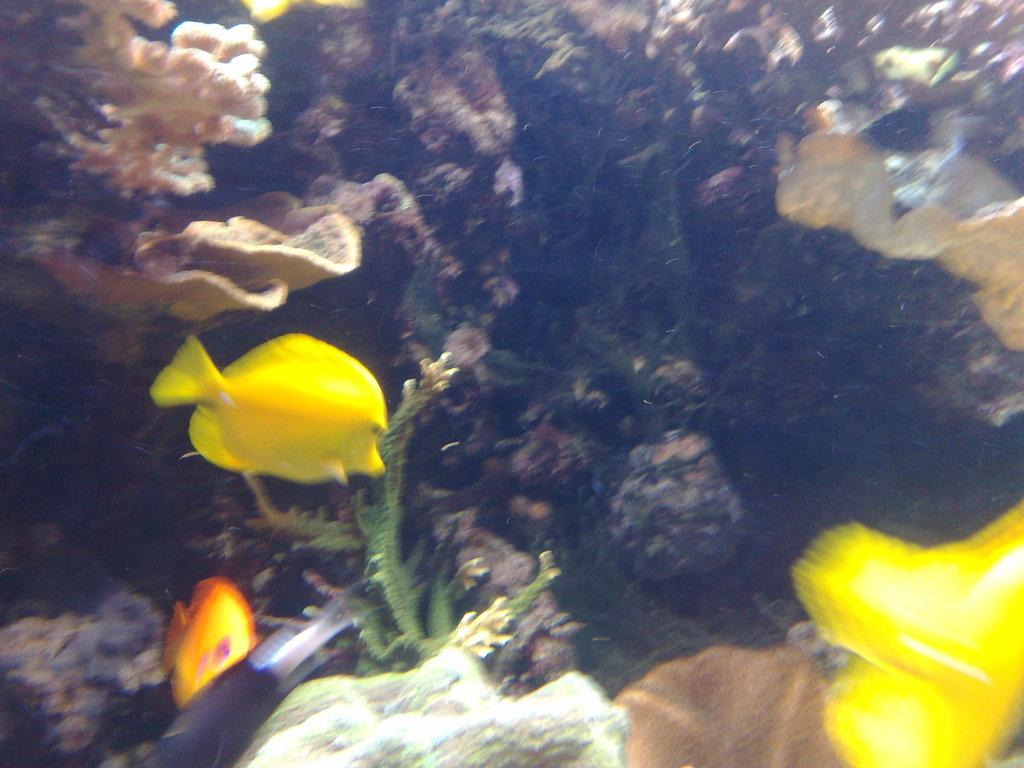What is the primary element in the image? There is water in the image. What can be found living in the water? There are fishes in the water. Are there any plants visible in the image? Yes, there are plants in the water. What type of curtain can be seen hanging in the water? There is no curtain present in the image; it features water with fishes and plants. 